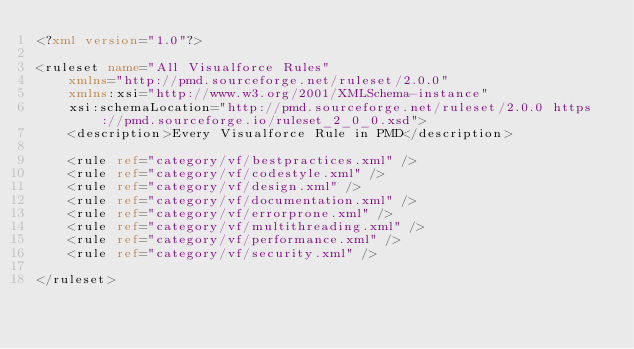<code> <loc_0><loc_0><loc_500><loc_500><_XML_><?xml version="1.0"?>

<ruleset name="All Visualforce Rules" 
    xmlns="http://pmd.sourceforge.net/ruleset/2.0.0"
    xmlns:xsi="http://www.w3.org/2001/XMLSchema-instance"
    xsi:schemaLocation="http://pmd.sourceforge.net/ruleset/2.0.0 https://pmd.sourceforge.io/ruleset_2_0_0.xsd">
    <description>Every Visualforce Rule in PMD</description>

    <rule ref="category/vf/bestpractices.xml" />
    <rule ref="category/vf/codestyle.xml" />
    <rule ref="category/vf/design.xml" />
    <rule ref="category/vf/documentation.xml" />
    <rule ref="category/vf/errorprone.xml" />
    <rule ref="category/vf/multithreading.xml" />
    <rule ref="category/vf/performance.xml" />
    <rule ref="category/vf/security.xml" />

</ruleset>
</code> 